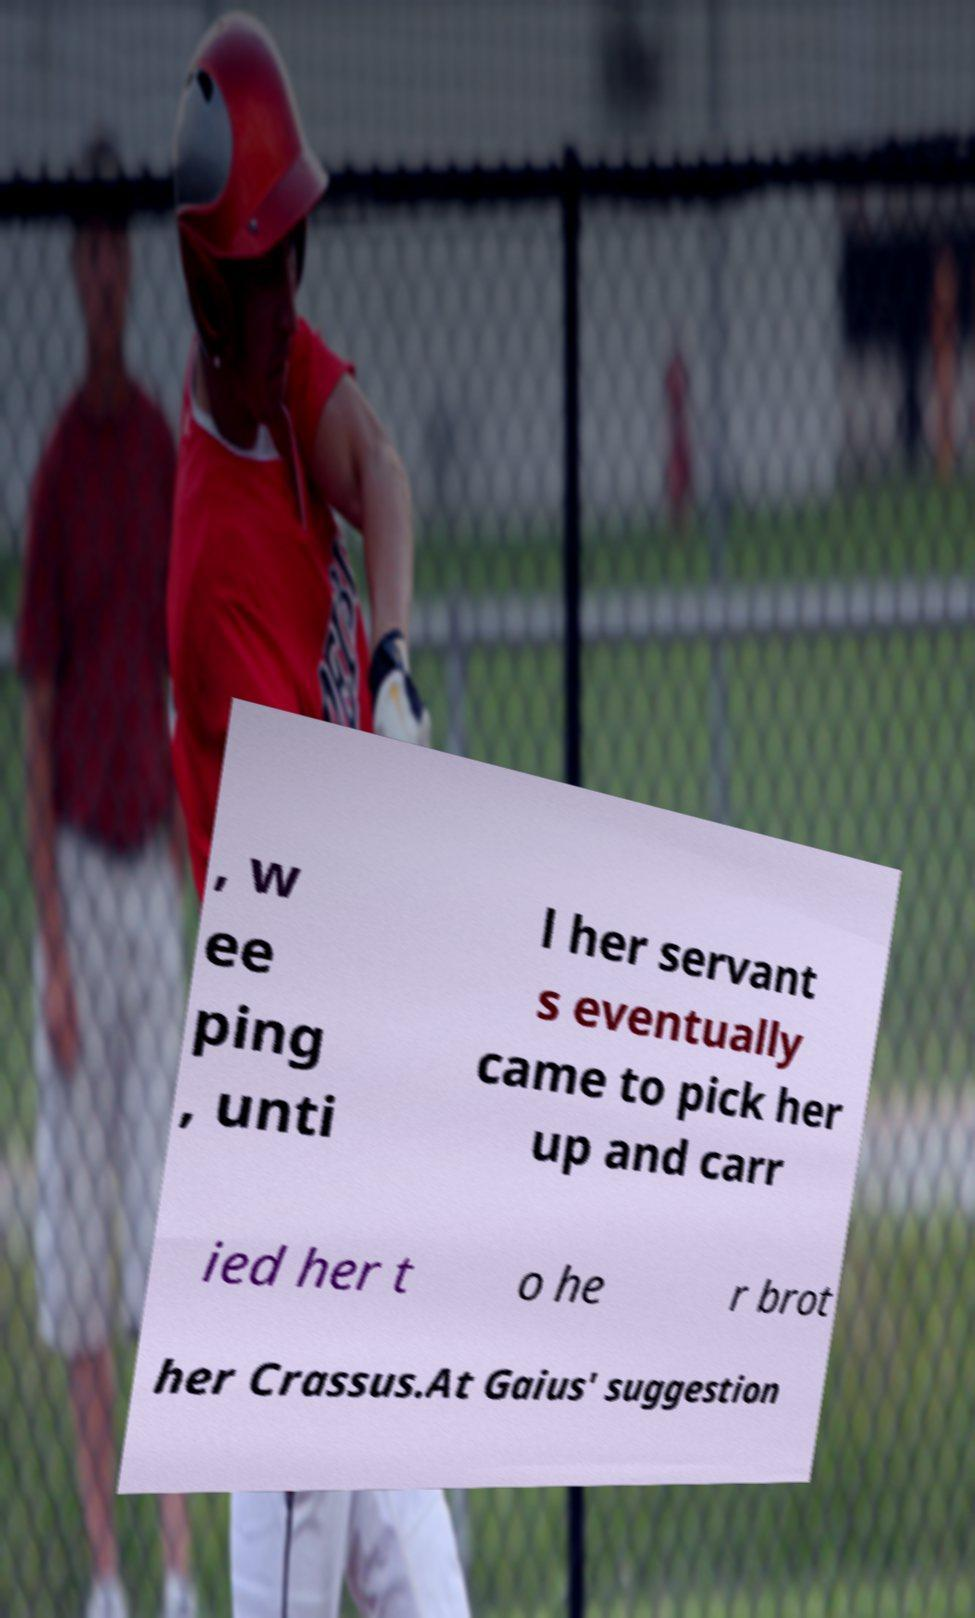Can you accurately transcribe the text from the provided image for me? , w ee ping , unti l her servant s eventually came to pick her up and carr ied her t o he r brot her Crassus.At Gaius' suggestion 